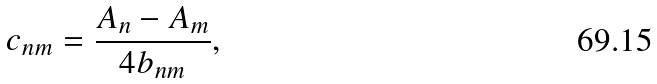Convert formula to latex. <formula><loc_0><loc_0><loc_500><loc_500>c _ { n m } = \frac { A _ { n } - A _ { m } } { 4 b _ { n m } } ,</formula> 